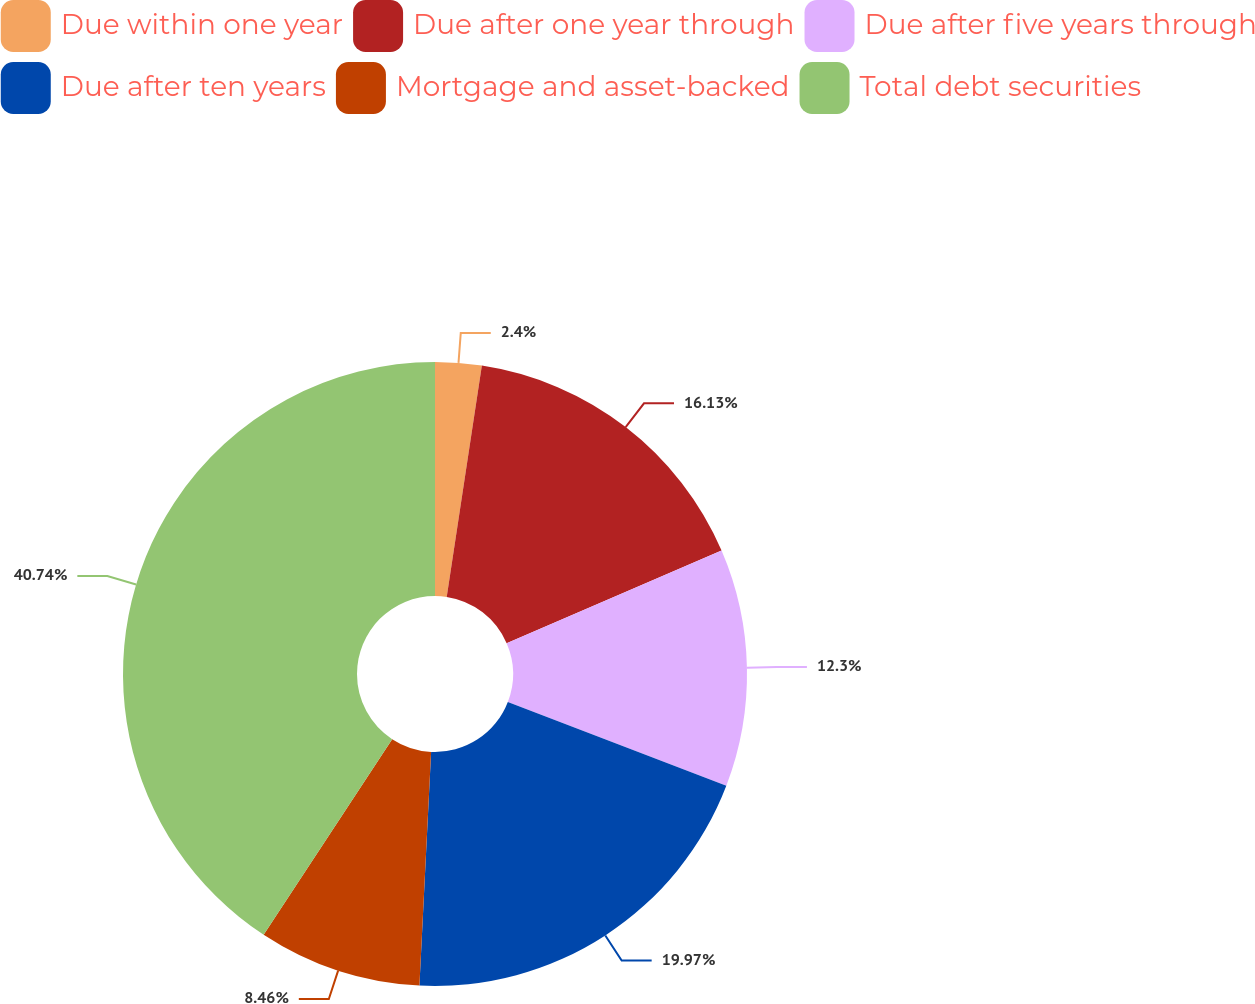Convert chart to OTSL. <chart><loc_0><loc_0><loc_500><loc_500><pie_chart><fcel>Due within one year<fcel>Due after one year through<fcel>Due after five years through<fcel>Due after ten years<fcel>Mortgage and asset-backed<fcel>Total debt securities<nl><fcel>2.4%<fcel>16.13%<fcel>12.3%<fcel>19.97%<fcel>8.46%<fcel>40.75%<nl></chart> 